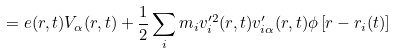<formula> <loc_0><loc_0><loc_500><loc_500>= e ( { r } , t ) { V } _ { \alpha } ( { r } , t ) + \frac { 1 } { 2 } \sum _ { i } m _ { i } v ^ { \prime 2 } _ { i } ( { r } , t ) v ^ { \prime } _ { i \alpha } ( { r } , t ) \phi \left [ { r } - { r } _ { i } ( t ) \right ]</formula> 